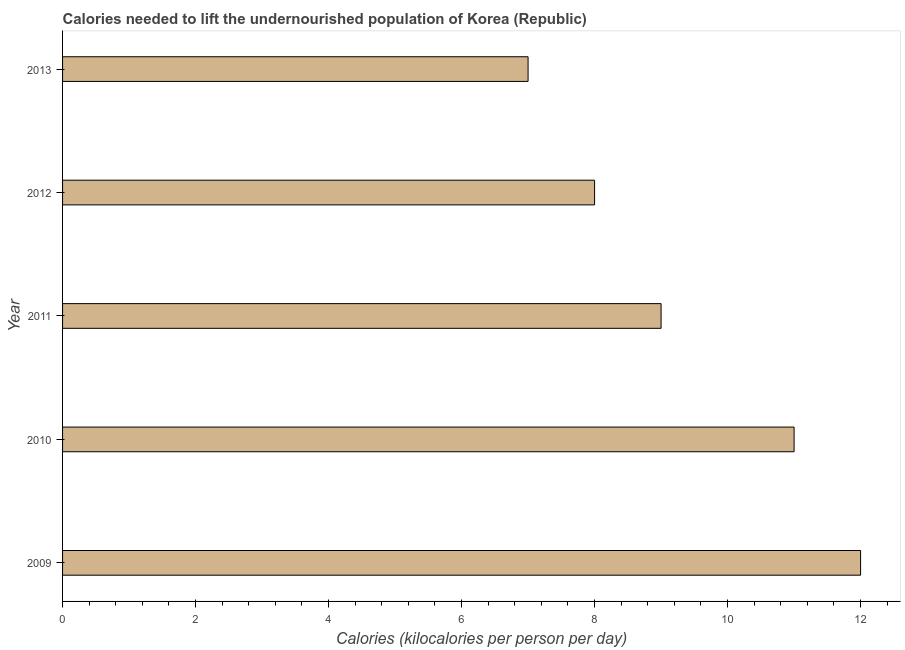Does the graph contain any zero values?
Your answer should be compact. No. What is the title of the graph?
Your response must be concise. Calories needed to lift the undernourished population of Korea (Republic). What is the label or title of the X-axis?
Keep it short and to the point. Calories (kilocalories per person per day). What is the label or title of the Y-axis?
Make the answer very short. Year. Across all years, what is the maximum depth of food deficit?
Ensure brevity in your answer.  12. Across all years, what is the minimum depth of food deficit?
Your response must be concise. 7. In which year was the depth of food deficit maximum?
Ensure brevity in your answer.  2009. What is the average depth of food deficit per year?
Ensure brevity in your answer.  9. In how many years, is the depth of food deficit greater than 5.6 kilocalories?
Make the answer very short. 5. Is the difference between the depth of food deficit in 2010 and 2013 greater than the difference between any two years?
Keep it short and to the point. No. Is the sum of the depth of food deficit in 2009 and 2011 greater than the maximum depth of food deficit across all years?
Make the answer very short. Yes. What is the difference between the highest and the lowest depth of food deficit?
Keep it short and to the point. 5. In how many years, is the depth of food deficit greater than the average depth of food deficit taken over all years?
Your response must be concise. 2. What is the difference between two consecutive major ticks on the X-axis?
Make the answer very short. 2. What is the Calories (kilocalories per person per day) of 2009?
Make the answer very short. 12. What is the Calories (kilocalories per person per day) in 2012?
Your answer should be compact. 8. What is the difference between the Calories (kilocalories per person per day) in 2009 and 2010?
Make the answer very short. 1. What is the difference between the Calories (kilocalories per person per day) in 2009 and 2011?
Provide a short and direct response. 3. What is the difference between the Calories (kilocalories per person per day) in 2009 and 2013?
Offer a terse response. 5. What is the difference between the Calories (kilocalories per person per day) in 2012 and 2013?
Provide a succinct answer. 1. What is the ratio of the Calories (kilocalories per person per day) in 2009 to that in 2010?
Keep it short and to the point. 1.09. What is the ratio of the Calories (kilocalories per person per day) in 2009 to that in 2011?
Keep it short and to the point. 1.33. What is the ratio of the Calories (kilocalories per person per day) in 2009 to that in 2013?
Your answer should be very brief. 1.71. What is the ratio of the Calories (kilocalories per person per day) in 2010 to that in 2011?
Give a very brief answer. 1.22. What is the ratio of the Calories (kilocalories per person per day) in 2010 to that in 2012?
Your answer should be compact. 1.38. What is the ratio of the Calories (kilocalories per person per day) in 2010 to that in 2013?
Ensure brevity in your answer.  1.57. What is the ratio of the Calories (kilocalories per person per day) in 2011 to that in 2012?
Offer a terse response. 1.12. What is the ratio of the Calories (kilocalories per person per day) in 2011 to that in 2013?
Your answer should be very brief. 1.29. What is the ratio of the Calories (kilocalories per person per day) in 2012 to that in 2013?
Offer a very short reply. 1.14. 